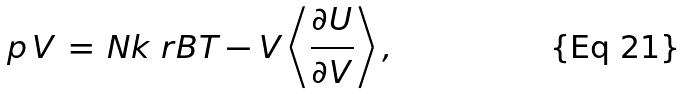<formula> <loc_0><loc_0><loc_500><loc_500>p \, V \, = \, N k _ { \ } r B T - V \left \langle \frac { \partial U } { \partial V } \right \rangle ,</formula> 